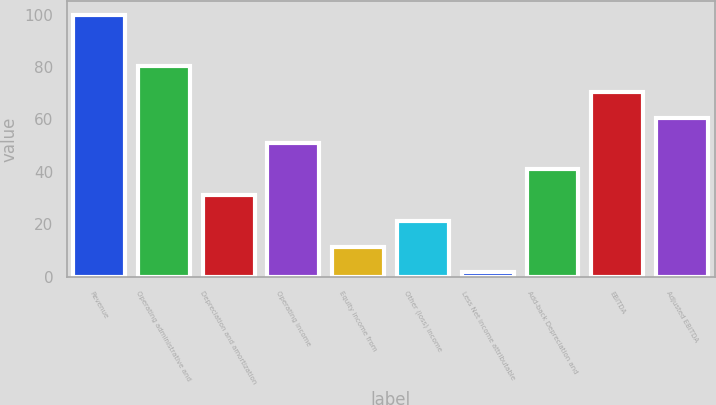<chart> <loc_0><loc_0><loc_500><loc_500><bar_chart><fcel>Revenue<fcel>Operating administrative and<fcel>Depreciation and amortization<fcel>Operating income<fcel>Equity income from<fcel>Other (loss) income<fcel>Less Net income attributable<fcel>Add-back Depreciation and<fcel>EBITDA<fcel>Adjusted EBITDA<nl><fcel>100<fcel>80.34<fcel>31.19<fcel>50.85<fcel>11.53<fcel>21.36<fcel>1.7<fcel>41.02<fcel>70.51<fcel>60.68<nl></chart> 